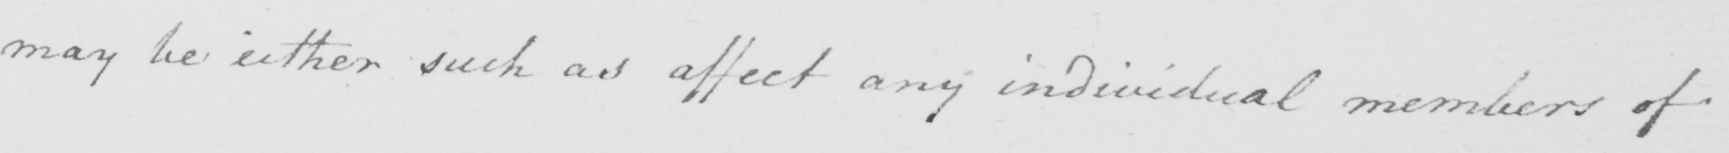Please provide the text content of this handwritten line. may be either such as affect any individual members of 